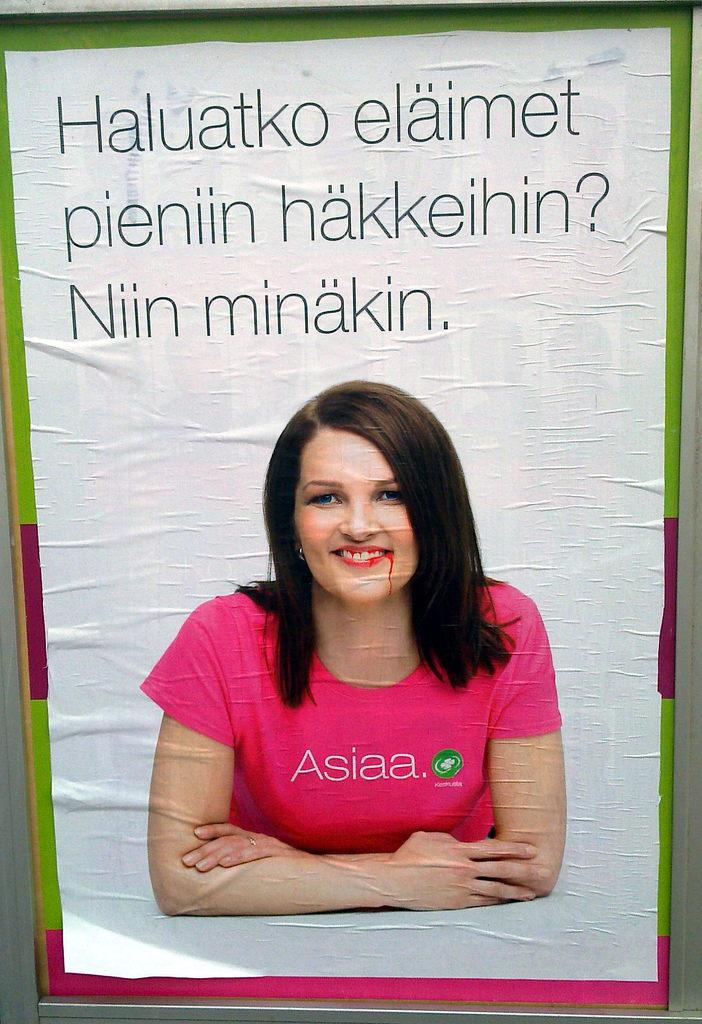What is the main subject of the poster in the image? The main subject of the poster in the image is a woman. What is the woman wearing in the poster? The woman is wearing a pink t-shirt in the poster. What is the woman's facial expression in the poster? The woman is smiling in the poster. What can be found at the top of the poster? There is text at the top of the poster. What type of attention is the woman seeking in the poster? The poster does not indicate that the woman is seeking any specific type of attention. Is there any indication of a fight or conflict involving the woman in the poster? No, there is no indication of a fight or conflict involving the woman in the poster. 